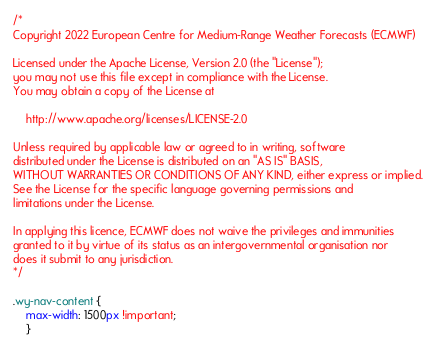<code> <loc_0><loc_0><loc_500><loc_500><_CSS_>/*
Copyright 2022 European Centre for Medium-Range Weather Forecasts (ECMWF)

Licensed under the Apache License, Version 2.0 (the "License");
you may not use this file except in compliance with the License.
You may obtain a copy of the License at

    http://www.apache.org/licenses/LICENSE-2.0

Unless required by applicable law or agreed to in writing, software
distributed under the License is distributed on an "AS IS" BASIS,
WITHOUT WARRANTIES OR CONDITIONS OF ANY KIND, either express or implied.
See the License for the specific language governing permissions and
limitations under the License.

In applying this licence, ECMWF does not waive the privileges and immunities
granted to it by virtue of its status as an intergovernmental organisation nor
does it submit to any jurisdiction.
*/

.wy-nav-content {
    max-width: 1500px !important;
    }</code> 